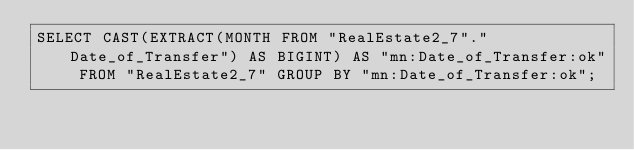<code> <loc_0><loc_0><loc_500><loc_500><_SQL_>SELECT CAST(EXTRACT(MONTH FROM "RealEstate2_7"."Date_of_Transfer") AS BIGINT) AS "mn:Date_of_Transfer:ok" FROM "RealEstate2_7" GROUP BY "mn:Date_of_Transfer:ok";
</code> 